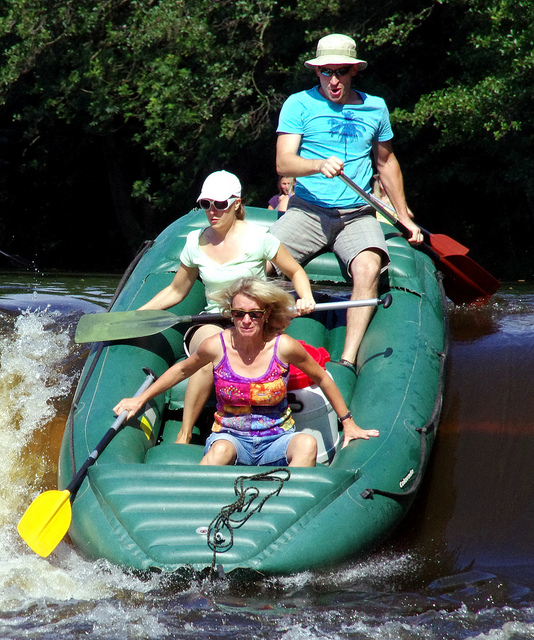What type of boat are they navigating the water on? A. canoe B. kayak C. fishing D. raft The group of individuals is navigating the water on a raft, which appears to be an inflatable craft designed for rough waters, likely whitewater rafting. Rafts, such as the one in the image, are sturdy and provide the buoyancy needed for safely traversing turbulent sections of a river. 